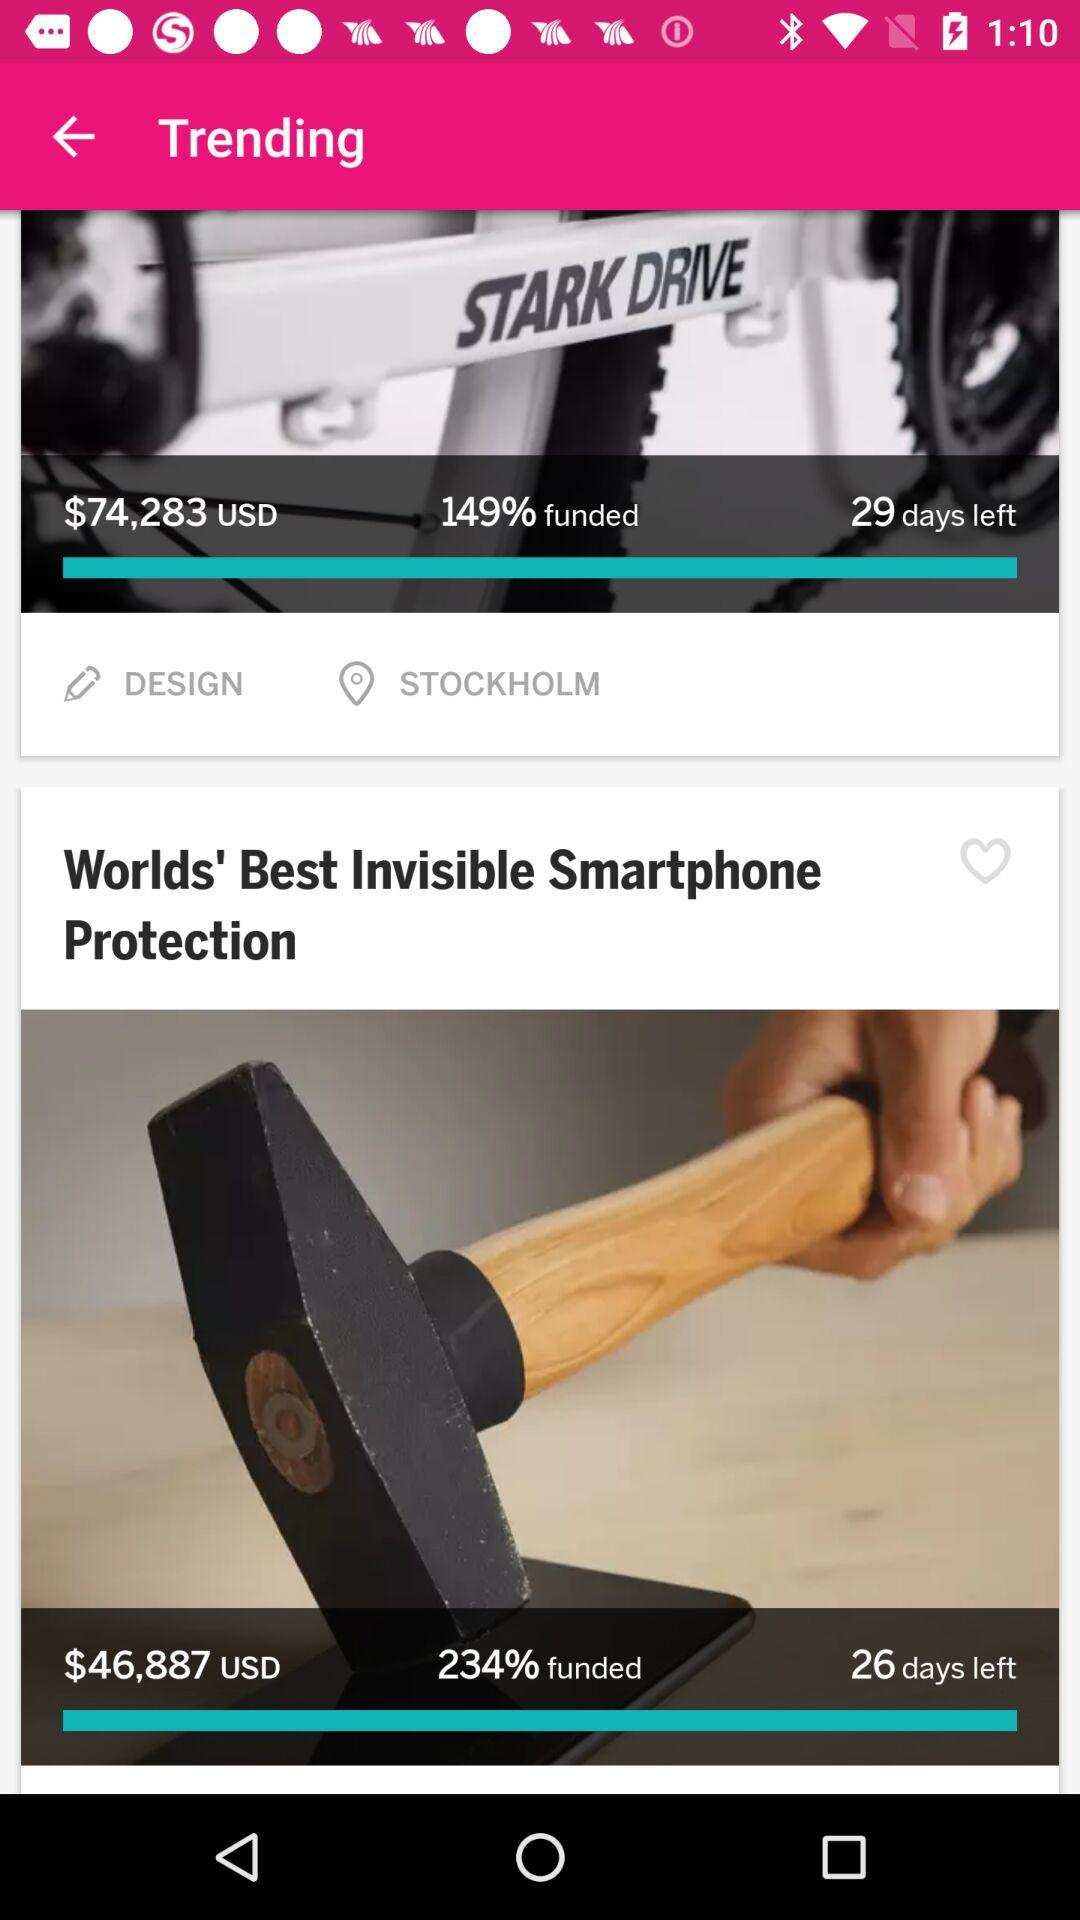What is the currency of price? The currency of price is the United States dollar. 